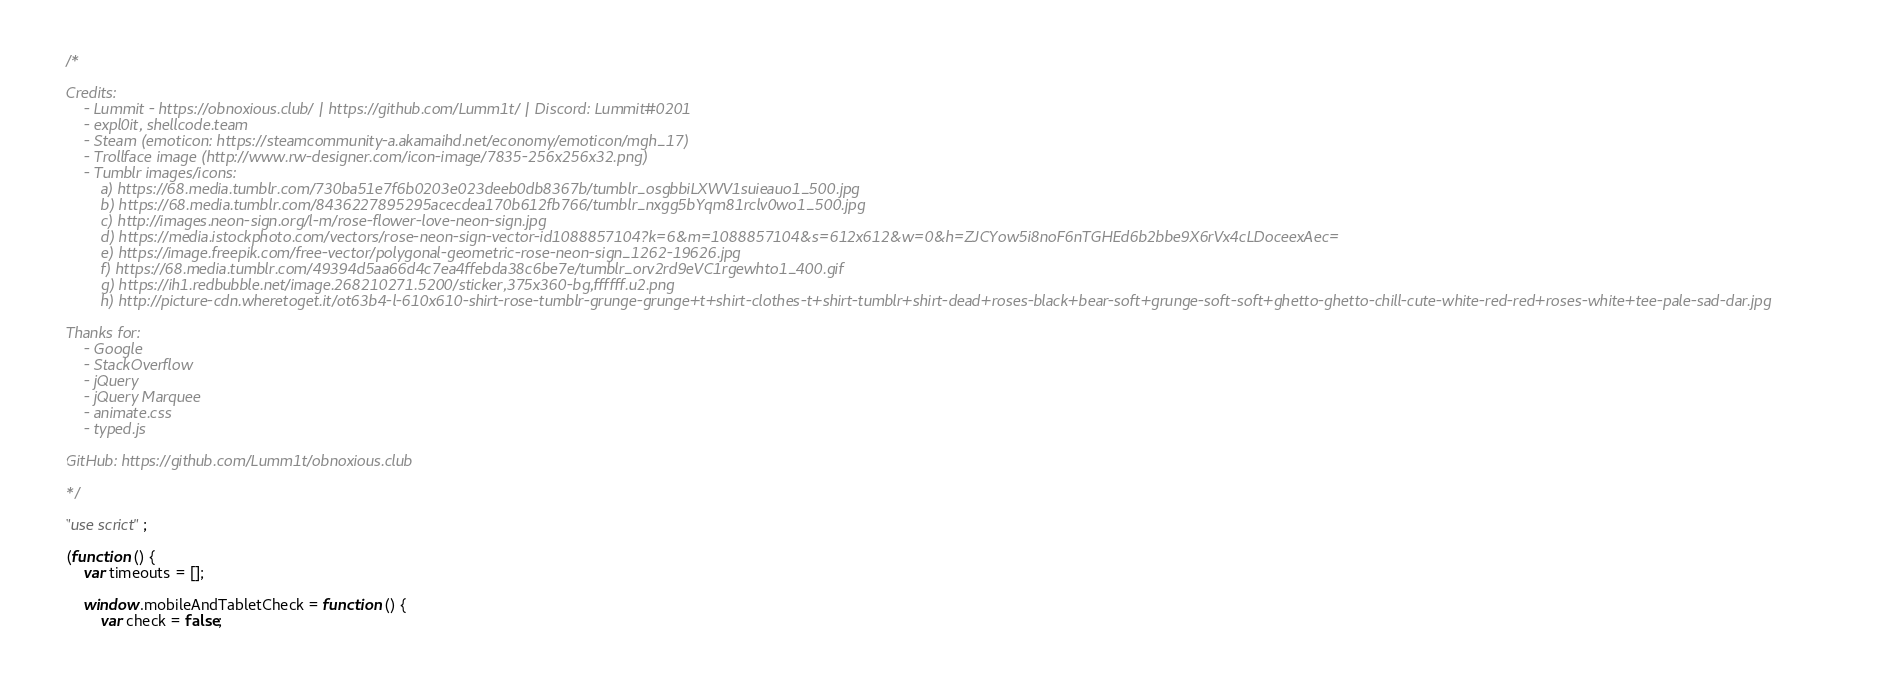<code> <loc_0><loc_0><loc_500><loc_500><_JavaScript_>/*

Credits:
    - Lummit - https://obnoxious.club/ | https://github.com/Lumm1t/ | Discord: Lummit#0201
    - expl0it, shellcode.team
    - Steam (emoticon: https://steamcommunity-a.akamaihd.net/economy/emoticon/mgh_17)
    - Trollface image (http://www.rw-designer.com/icon-image/7835-256x256x32.png)
    - Tumblr images/icons:
        a) https://68.media.tumblr.com/730ba51e7f6b0203e023deeb0db8367b/tumblr_osgbbiLXWV1suieauo1_500.jpg
        b) https://68.media.tumblr.com/8436227895295acecdea170b612fb766/tumblr_nxgg5bYqm81rclv0wo1_500.jpg
        c) http://images.neon-sign.org/l-m/rose-flower-love-neon-sign.jpg
        d) https://media.istockphoto.com/vectors/rose-neon-sign-vector-id1088857104?k=6&m=1088857104&s=612x612&w=0&h=ZJCYow5i8noF6nTGHEd6b2bbe9X6rVx4cLDoceexAec=
        e) https://image.freepik.com/free-vector/polygonal-geometric-rose-neon-sign_1262-19626.jpg
        f) https://68.media.tumblr.com/49394d5aa66d4c7ea4ffebda38c6be7e/tumblr_orv2rd9eVC1rgewhto1_400.gif
        g) https://ih1.redbubble.net/image.268210271.5200/sticker,375x360-bg,ffffff.u2.png
        h) http://picture-cdn.wheretoget.it/ot63b4-l-610x610-shirt-rose-tumblr-grunge-grunge+t+shirt-clothes-t+shirt-tumblr+shirt-dead+roses-black+bear-soft+grunge-soft-soft+ghetto-ghetto-chill-cute-white-red-red+roses-white+tee-pale-sad-dar.jpg

Thanks for:
    - Google
    - StackOverflow
    - jQuery
    - jQuery Marquee
    - animate.css
    - typed.js
    
GitHub: https://github.com/Lumm1t/obnoxious.club

*/

"use scrict";

(function () {
    var timeouts = [];

    window.mobileAndTabletCheck = function () {
        var check = false;</code> 